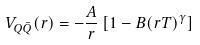<formula> <loc_0><loc_0><loc_500><loc_500>\ V _ { Q \bar { Q } } ( r ) = - \frac { A } { r } \left [ 1 - B ( r T ) ^ { \gamma } \right ]</formula> 